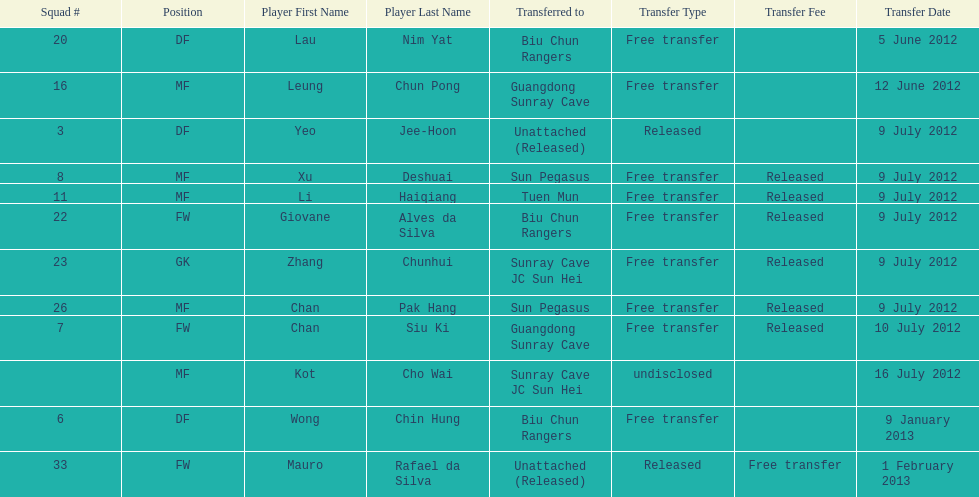How many consecutive players were released on july 9? 6. 